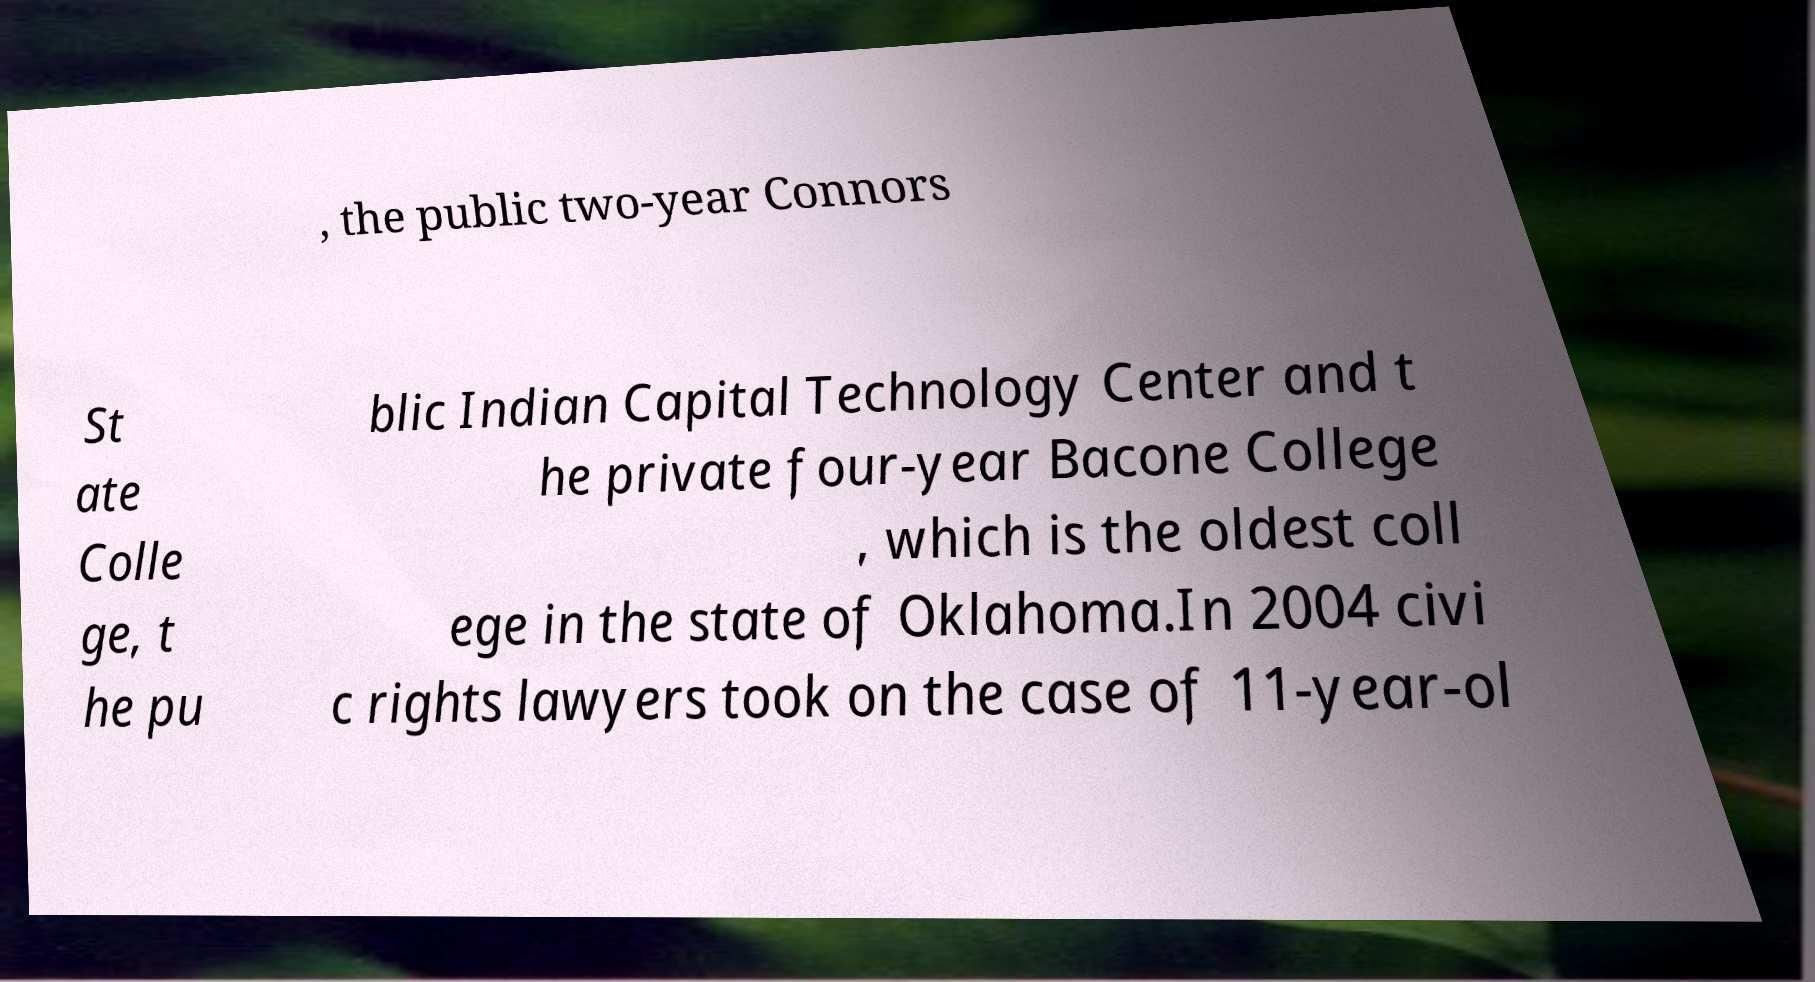Please read and relay the text visible in this image. What does it say? , the public two-year Connors St ate Colle ge, t he pu blic Indian Capital Technology Center and t he private four-year Bacone College , which is the oldest coll ege in the state of Oklahoma.In 2004 civi c rights lawyers took on the case of 11-year-ol 